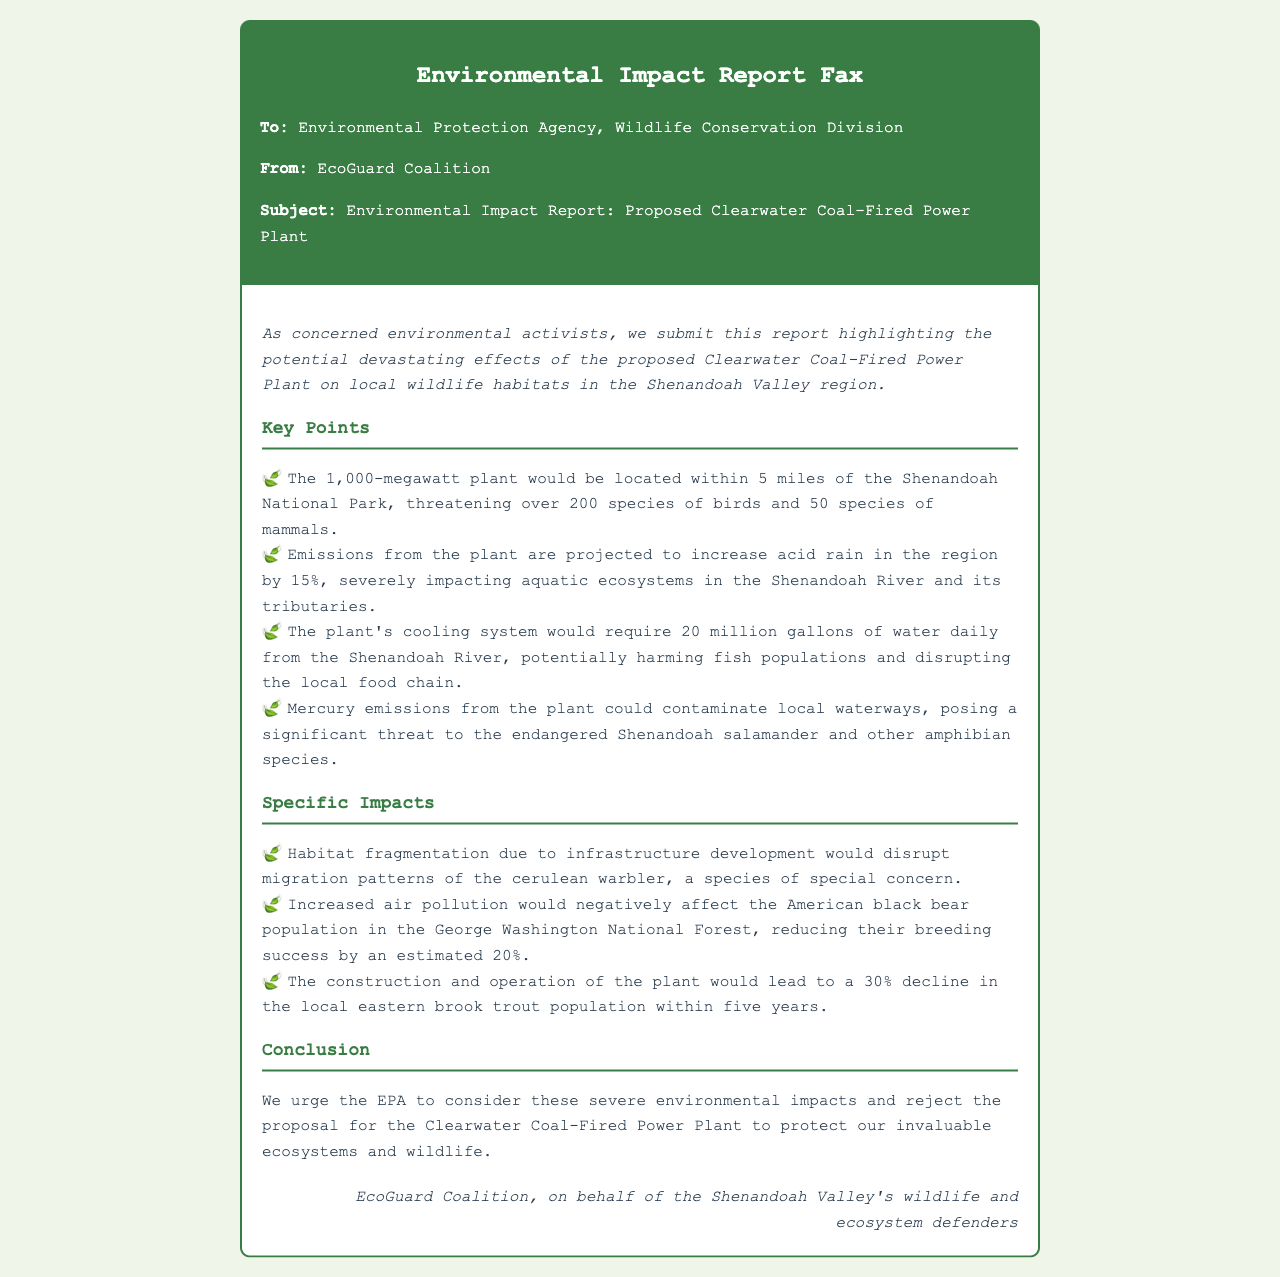What is the location of the proposed coal-fired power plant? The proposed coal-fired power plant is planned to be located within 5 miles of the Shenandoah National Park.
Answer: 5 miles How many species of birds are threatened by the power plant? The document states that the power plant threatens over 200 species of birds.
Answer: 200 species What is the projected increase in acid rain due to the plant's emissions? The report mentions a projected increase in acid rain of 15% in the region.
Answer: 15% How much water will the plant's cooling system require daily? The cooling system for the plant would require 20 million gallons of water daily from the Shenandoah River.
Answer: 20 million gallons What species’ migration patterns will be disrupted? The migration patterns of the cerulean warbler will be disrupted due to habitat fragmentation.
Answer: cerulean warbler What is the expected decline in the eastern brook trout population? The document indicates a projected decline of 30% in the local eastern brook trout population within five years.
Answer: 30% Who submitted the report? The report was submitted by EcoGuard Coalition.
Answer: EcoGuard Coalition What is the potential effect of increased air pollution on American black bears? Increased air pollution is estimated to reduce the breeding success of the American black bear population by 20%.
Answer: 20% What is the conclusion drawn by the EcoGuard Coalition? The conclusion urges the EPA to reject the proposal for the Clearwater Coal-Fired Power Plant to protect ecosystems and wildlife.
Answer: reject the proposal 